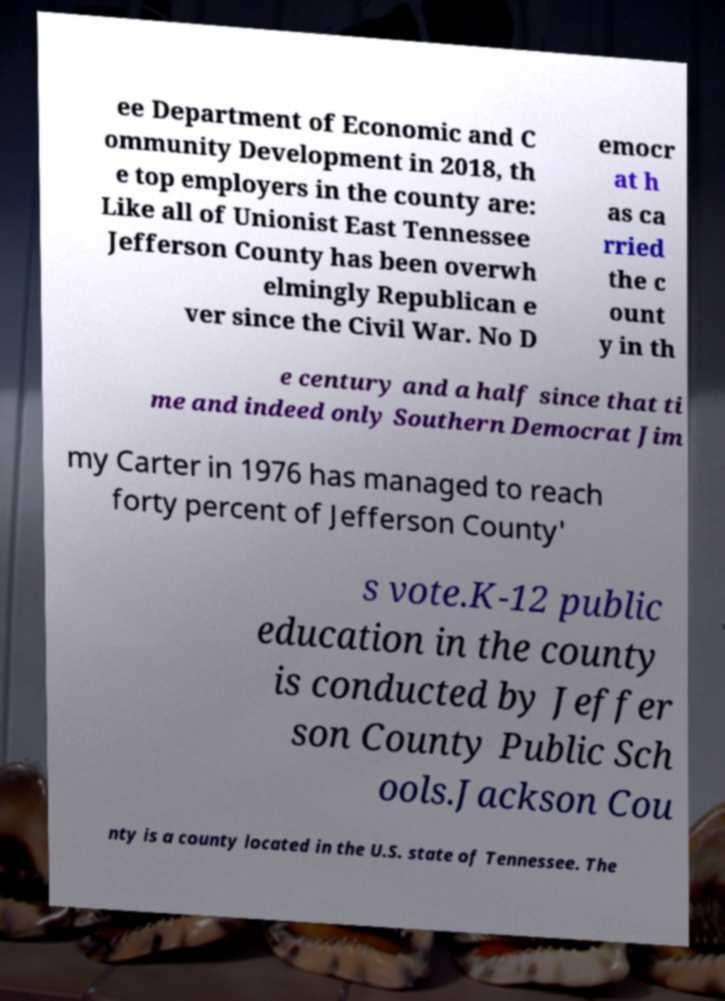Please identify and transcribe the text found in this image. ee Department of Economic and C ommunity Development in 2018, th e top employers in the county are: Like all of Unionist East Tennessee Jefferson County has been overwh elmingly Republican e ver since the Civil War. No D emocr at h as ca rried the c ount y in th e century and a half since that ti me and indeed only Southern Democrat Jim my Carter in 1976 has managed to reach forty percent of Jefferson County' s vote.K-12 public education in the county is conducted by Jeffer son County Public Sch ools.Jackson Cou nty is a county located in the U.S. state of Tennessee. The 